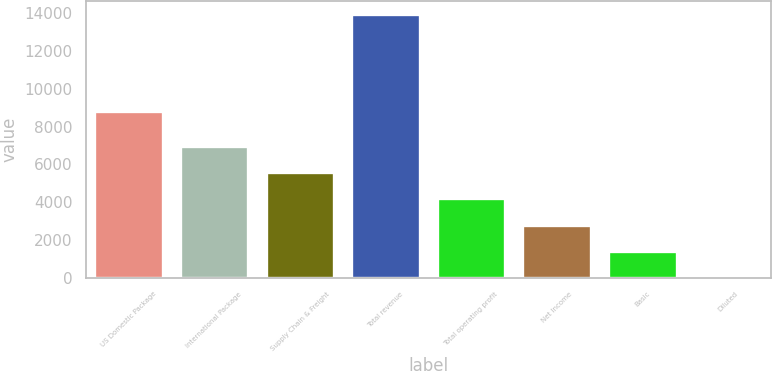Convert chart. <chart><loc_0><loc_0><loc_500><loc_500><bar_chart><fcel>US Domestic Package<fcel>International Package<fcel>Supply Chain & Freight<fcel>Total revenue<fcel>Total operating profit<fcel>Net Income<fcel>Basic<fcel>Diluted<nl><fcel>8814<fcel>6989.07<fcel>5591.48<fcel>13977<fcel>4193.89<fcel>2796.3<fcel>1398.71<fcel>1.12<nl></chart> 